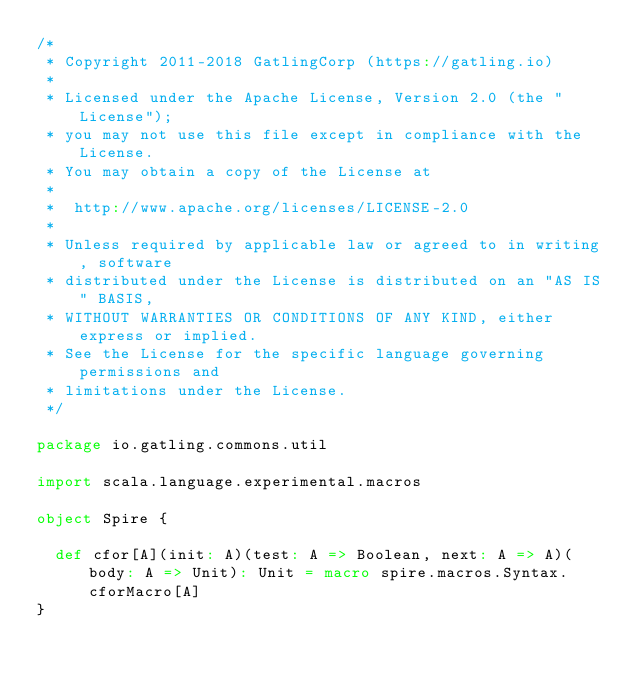Convert code to text. <code><loc_0><loc_0><loc_500><loc_500><_Scala_>/*
 * Copyright 2011-2018 GatlingCorp (https://gatling.io)
 *
 * Licensed under the Apache License, Version 2.0 (the "License");
 * you may not use this file except in compliance with the License.
 * You may obtain a copy of the License at
 *
 *  http://www.apache.org/licenses/LICENSE-2.0
 *
 * Unless required by applicable law or agreed to in writing, software
 * distributed under the License is distributed on an "AS IS" BASIS,
 * WITHOUT WARRANTIES OR CONDITIONS OF ANY KIND, either express or implied.
 * See the License for the specific language governing permissions and
 * limitations under the License.
 */

package io.gatling.commons.util

import scala.language.experimental.macros

object Spire {

  def cfor[A](init: A)(test: A => Boolean, next: A => A)(body: A => Unit): Unit = macro spire.macros.Syntax.cforMacro[A]
}
</code> 